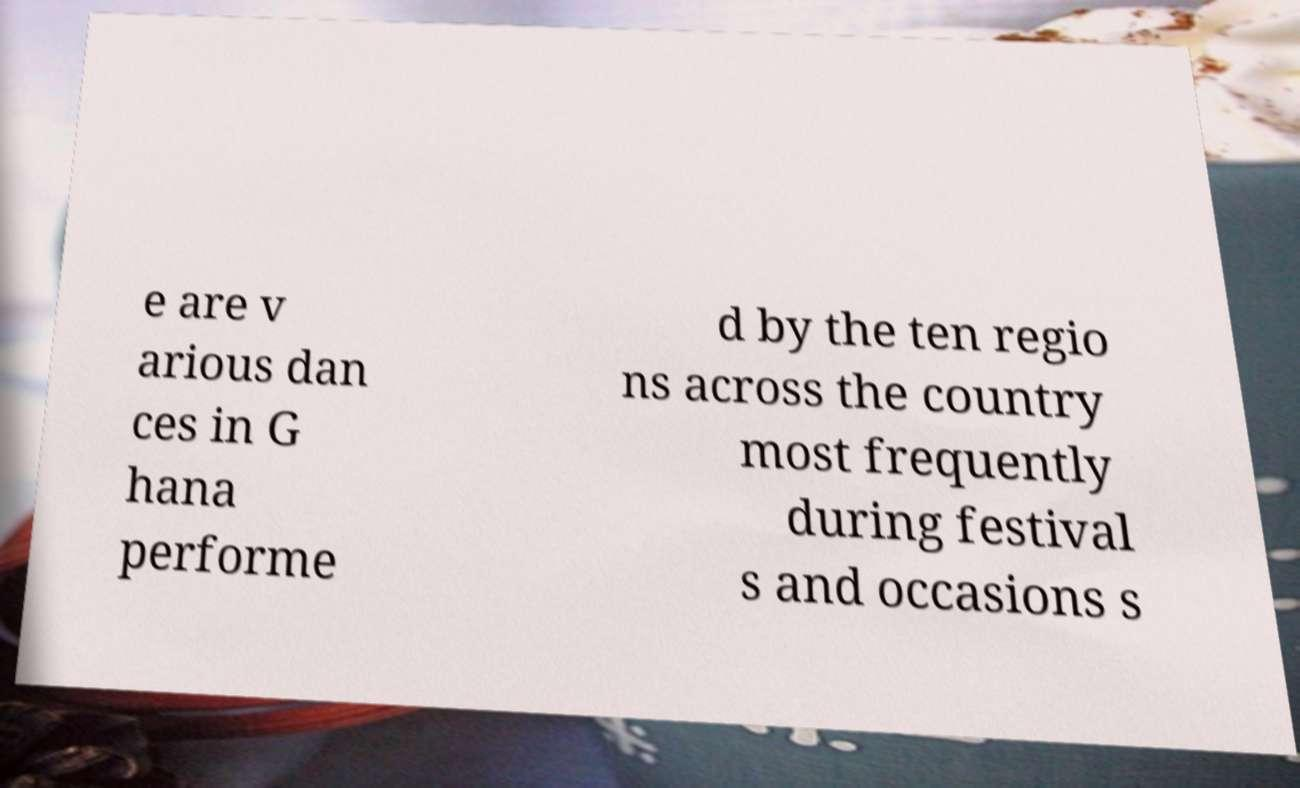Can you read and provide the text displayed in the image?This photo seems to have some interesting text. Can you extract and type it out for me? e are v arious dan ces in G hana performe d by the ten regio ns across the country most frequently during festival s and occasions s 